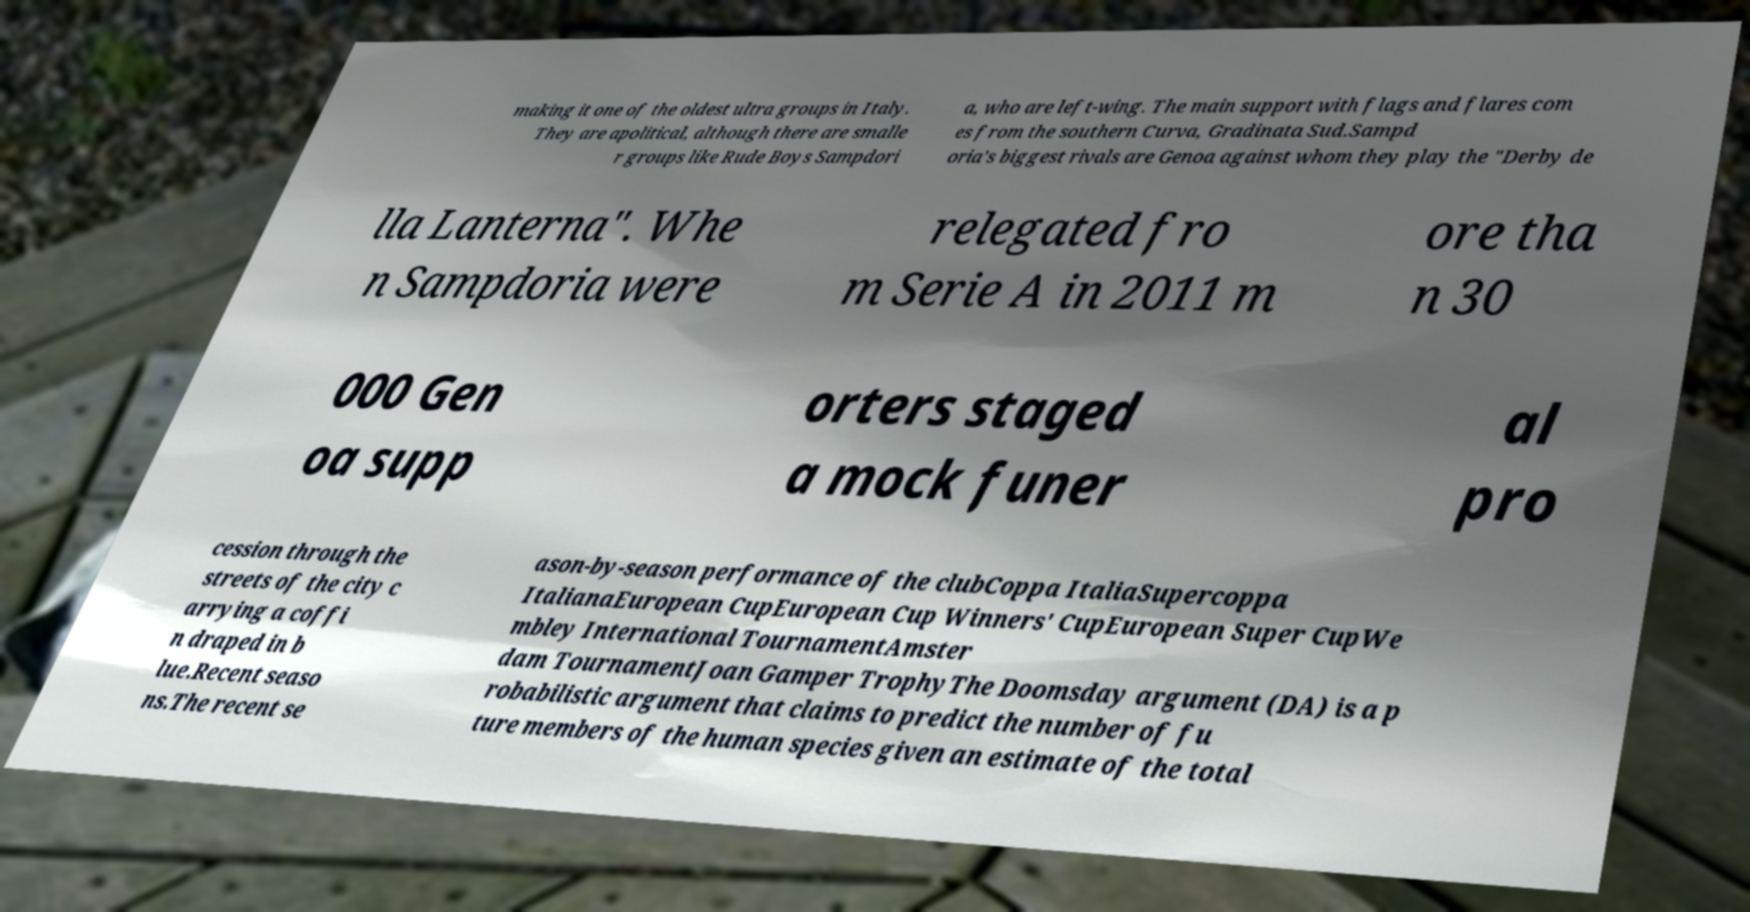Please read and relay the text visible in this image. What does it say? making it one of the oldest ultra groups in Italy. They are apolitical, although there are smalle r groups like Rude Boys Sampdori a, who are left-wing. The main support with flags and flares com es from the southern Curva, Gradinata Sud.Sampd oria's biggest rivals are Genoa against whom they play the "Derby de lla Lanterna". Whe n Sampdoria were relegated fro m Serie A in 2011 m ore tha n 30 000 Gen oa supp orters staged a mock funer al pro cession through the streets of the city c arrying a coffi n draped in b lue.Recent seaso ns.The recent se ason-by-season performance of the clubCoppa ItaliaSupercoppa ItalianaEuropean CupEuropean Cup Winners' CupEuropean Super CupWe mbley International TournamentAmster dam TournamentJoan Gamper TrophyThe Doomsday argument (DA) is a p robabilistic argument that claims to predict the number of fu ture members of the human species given an estimate of the total 